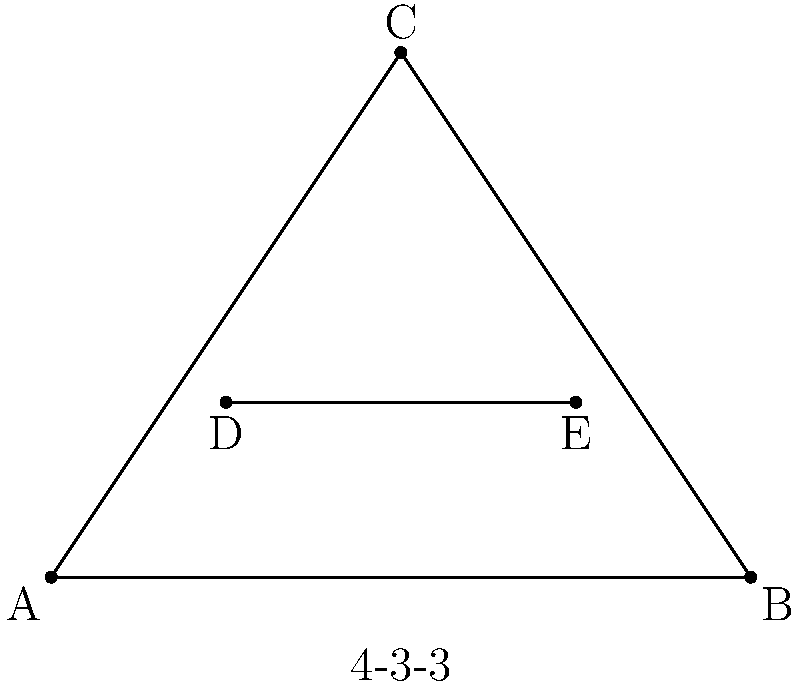En el contexto de un análisis de las formaciones más eficientes para diferentes estrategias de equipo en fútbol, considera la formación 4-3-3 representada en el diagrama. Si el triángulo ABC representa el área de cobertura de los tres delanteros, y la línea DE representa la posición de dos de los mediocampistas, ¿cuál es la relación entre el área del triángulo ABC y la longitud de la línea DE que maximizaría la eficiencia ofensiva del equipo? Para resolver este problema, seguiremos estos pasos:

1) El área del triángulo ABC representa la cobertura ofensiva de los delanteros. Un área mayor indica una mayor presencia en el campo contrario.

2) La longitud de la línea DE representa la conexión entre los mediocampistas. Una línea más larga indica una mayor amplitud en el juego.

3) La eficiencia ofensiva se maximiza cuando hay un equilibrio entre la cobertura de los delanteros y la amplitud del juego de los mediocampistas.

4) Matemáticamente, podemos expresar esto como una relación entre el área del triángulo y la longitud de la línea:

   $$ \text{Eficiencia} = \frac{\text{Área del triángulo ABC}}{\text{Longitud de DE}} $$

5) Para maximizar esta relación, el área del triángulo debe ser lo más grande posible mientras que la longitud DE se mantiene óptima para el control del mediocampo.

6) En la práctica, esto se traduce en que los delanteros deben cubrir un área amplia (triángulo grande) mientras que los mediocampistas mantienen una distancia óptima entre sí (DE no demasiado larga) para facilitar los pases y el control del juego.

7) La relación ideal dependerá de factores como el estilo de juego del equipo, las características de los jugadores y la estrategia del oponente, pero generalmente se busca que el área del triángulo sea aproximadamente el cuadrado de la longitud DE.
Answer: $\frac{\text{Área ABC}}{(\text{Longitud DE})^2} \approx 1$ 